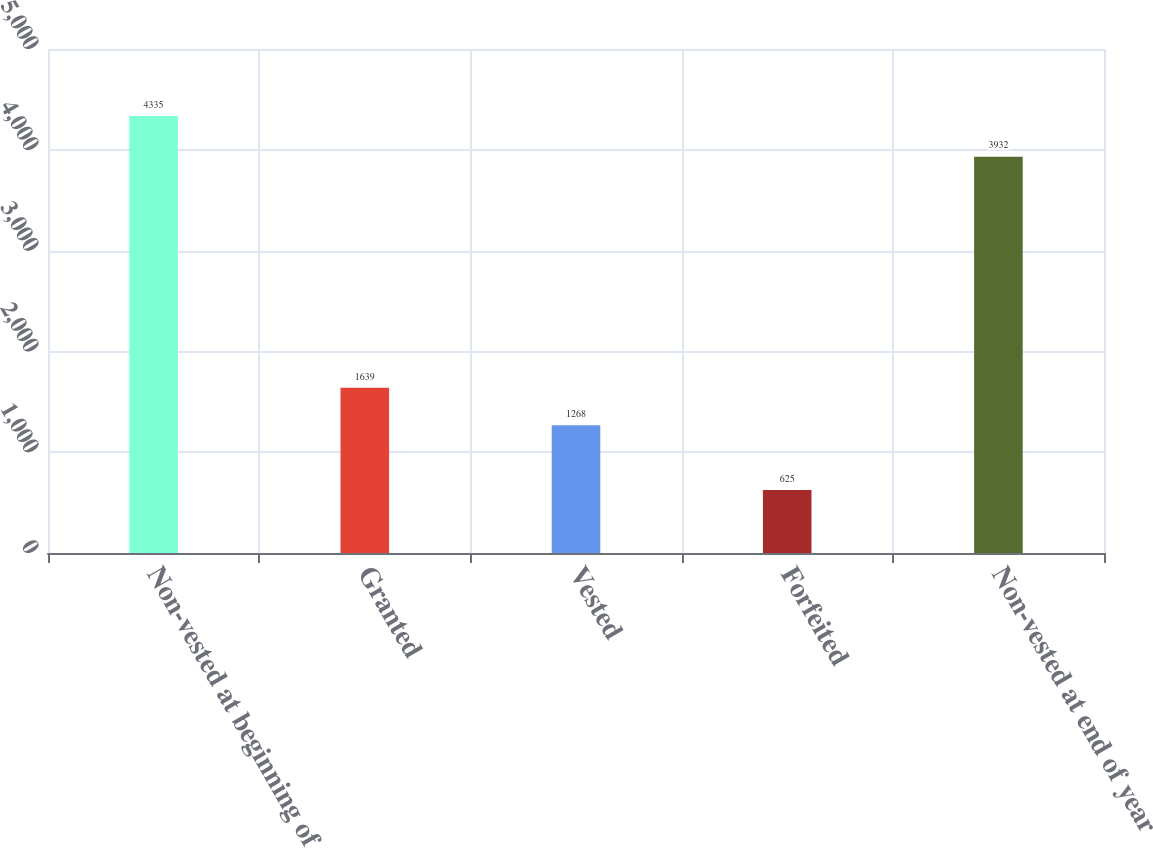Convert chart. <chart><loc_0><loc_0><loc_500><loc_500><bar_chart><fcel>Non-vested at beginning of<fcel>Granted<fcel>Vested<fcel>Forfeited<fcel>Non-vested at end of year<nl><fcel>4335<fcel>1639<fcel>1268<fcel>625<fcel>3932<nl></chart> 